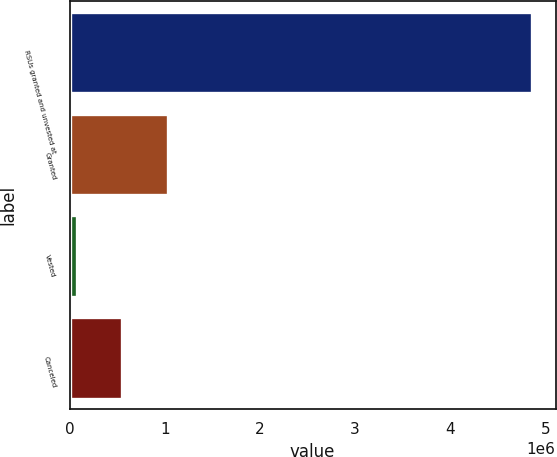<chart> <loc_0><loc_0><loc_500><loc_500><bar_chart><fcel>RSUs granted and unvested at<fcel>Granted<fcel>Vested<fcel>Canceled<nl><fcel>4.8621e+06<fcel>1.03422e+06<fcel>77250<fcel>555735<nl></chart> 